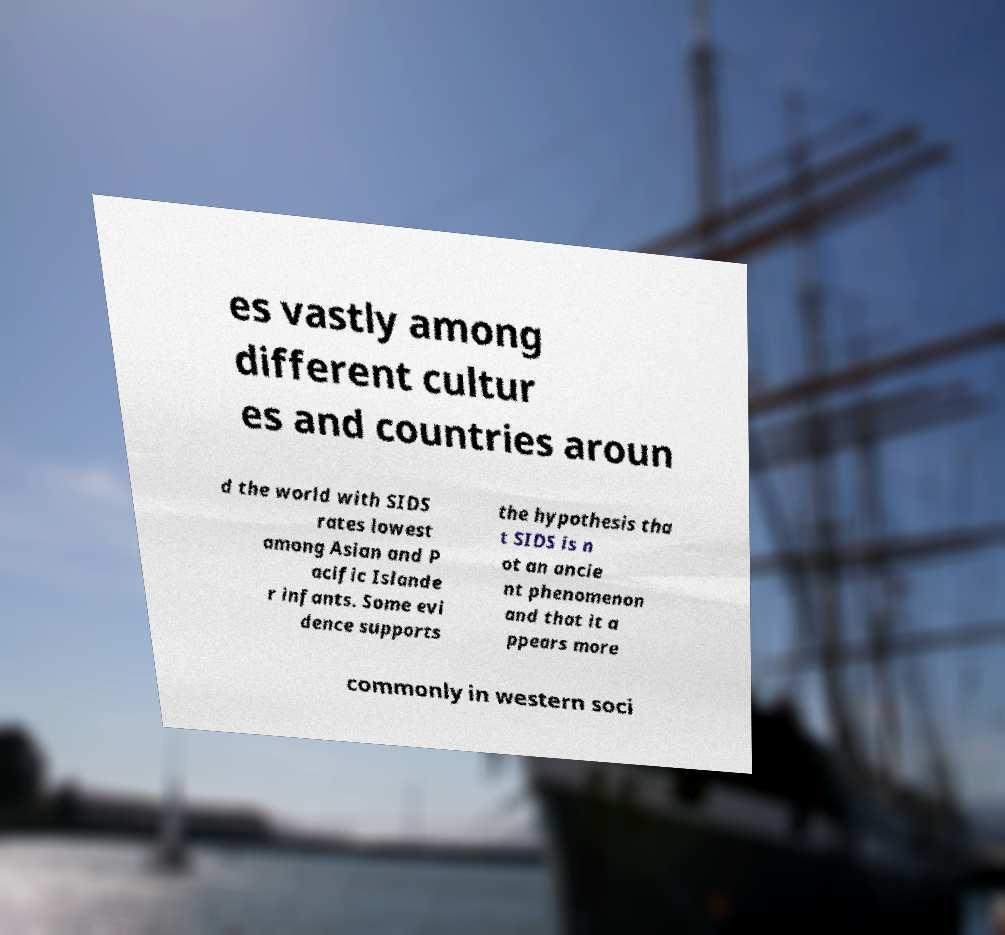Can you accurately transcribe the text from the provided image for me? es vastly among different cultur es and countries aroun d the world with SIDS rates lowest among Asian and P acific Islande r infants. Some evi dence supports the hypothesis tha t SIDS is n ot an ancie nt phenomenon and that it a ppears more commonly in western soci 